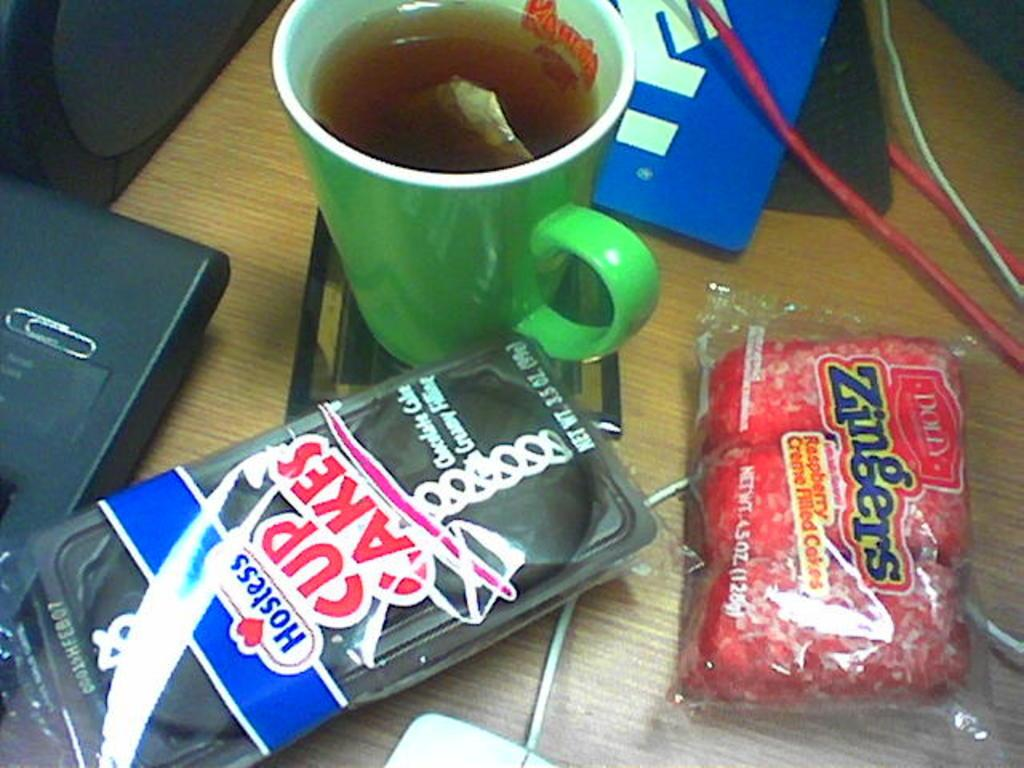What is in the mug that is visible in the image? There is a mug with liquid in the image. What else can be seen in the image besides the mug? There are packets and wires visible in the image. What is the object on the wooden platform in the image? The object on the wooden platform is not specified in the facts, but it is mentioned that there is an object on a wooden platform. What might be used for connecting or transmitting in the image? The wires in the image might be used for connecting or transmitting. What is the size of the lead in the image? There is no lead present in the image. 